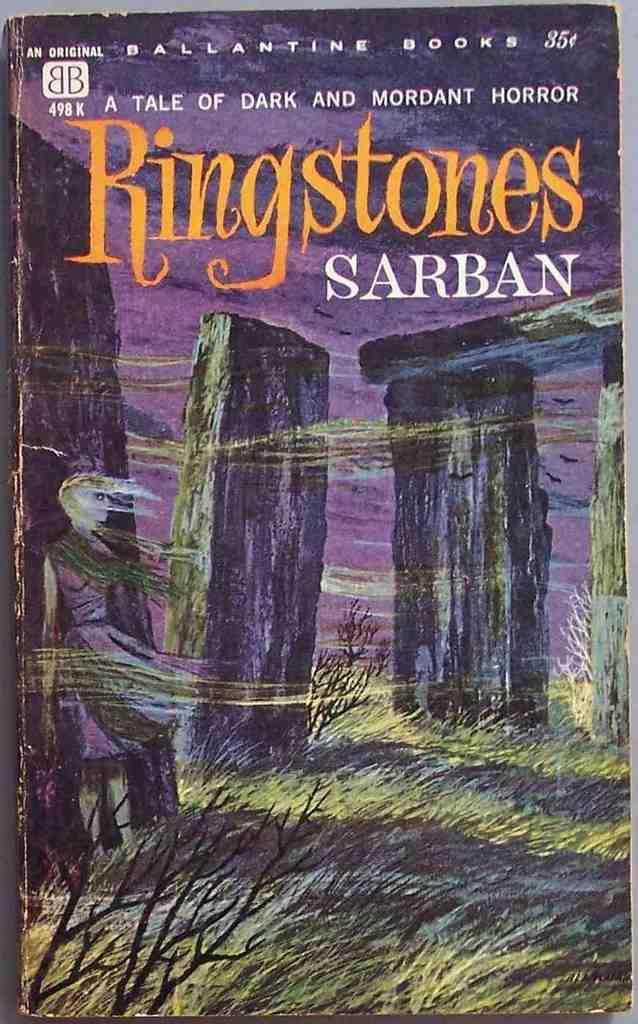Who is the publisher?
Provide a succinct answer. Ballantine books. What is the title of the book?
Give a very brief answer. Ringstones. 